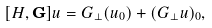<formula> <loc_0><loc_0><loc_500><loc_500>[ H , \mathbf G ] u = G _ { \perp } ( u _ { 0 } ) + ( G _ { \perp } u ) _ { 0 } ,</formula> 